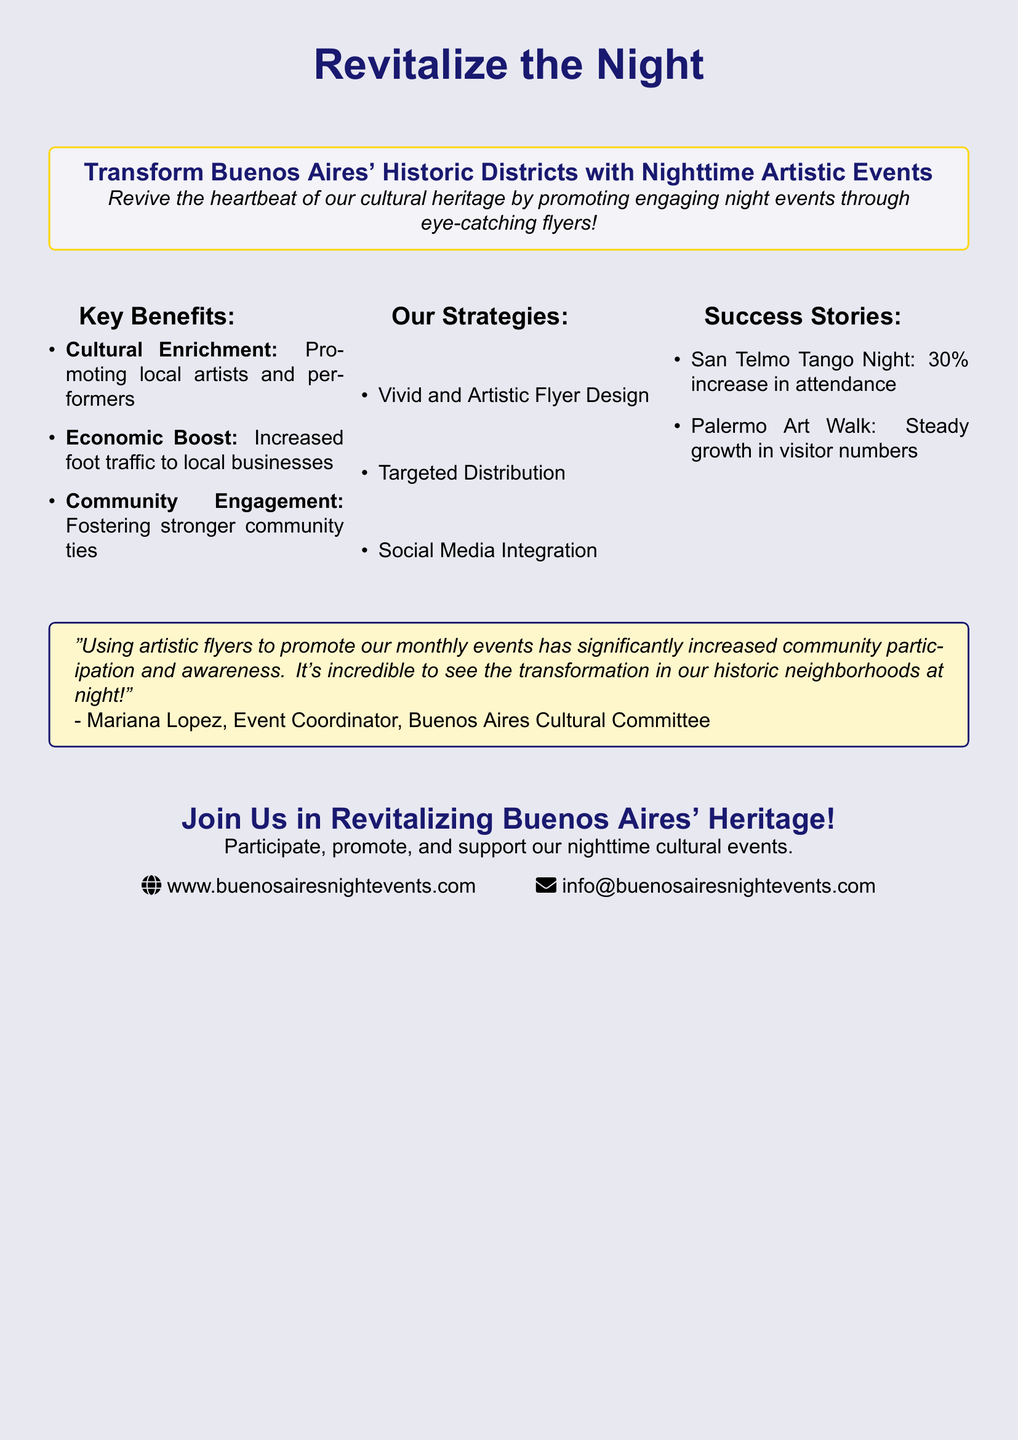What is the title of the advertisement? The title of the advertisement is prominently displayed at the top of the document.
Answer: Revitalize the Night What is one key benefit mentioned in the advertisement? The advertisement lists key benefits of the initiative, including cultural enrichment and economic boost.
Answer: Cultural Enrichment What percentage increase in attendance is mentioned for the San Telmo Tango Night? The document specifies the success story related to attendance at an event.
Answer: 30% What is one of the strategies outlined in the document? The advertisement provides several strategies used to promote nighttime events.
Answer: Vivid and Artistic Flyer Design Who is quoted in the advertisement? The quote provides insight into the impact of promoting monthly events on community participation.
Answer: Mariana Lopez What color scheme is used in the advertisement? The document employs a specific color scheme throughout the design, noticeable in headings and boxes.
Answer: Night Blue and Gold Accent How can one participate in the events? The advertisement encourages the community's involvement in the nighttime cultural events.
Answer: Participate, promote, and support What is the website mentioned for more information? The advertisement provides contact details for further engagement with the initiative.
Answer: www.buenosairesnightevents.com What community benefit is highlighted in the flyer? The advertisement emphasizes the importance of community ties as a benefit of the events.
Answer: Community Engagement 